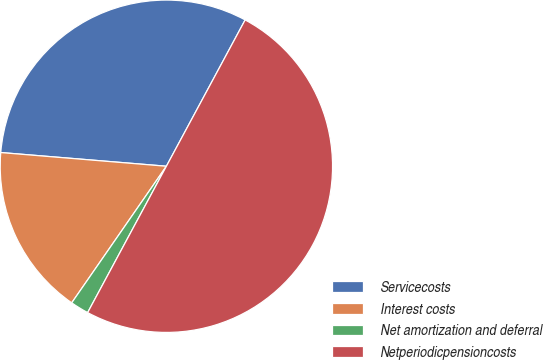Convert chart. <chart><loc_0><loc_0><loc_500><loc_500><pie_chart><fcel>Servicecosts<fcel>Interest costs<fcel>Net amortization and deferral<fcel>Netperiodicpensioncosts<nl><fcel>31.55%<fcel>16.67%<fcel>1.79%<fcel>50.0%<nl></chart> 